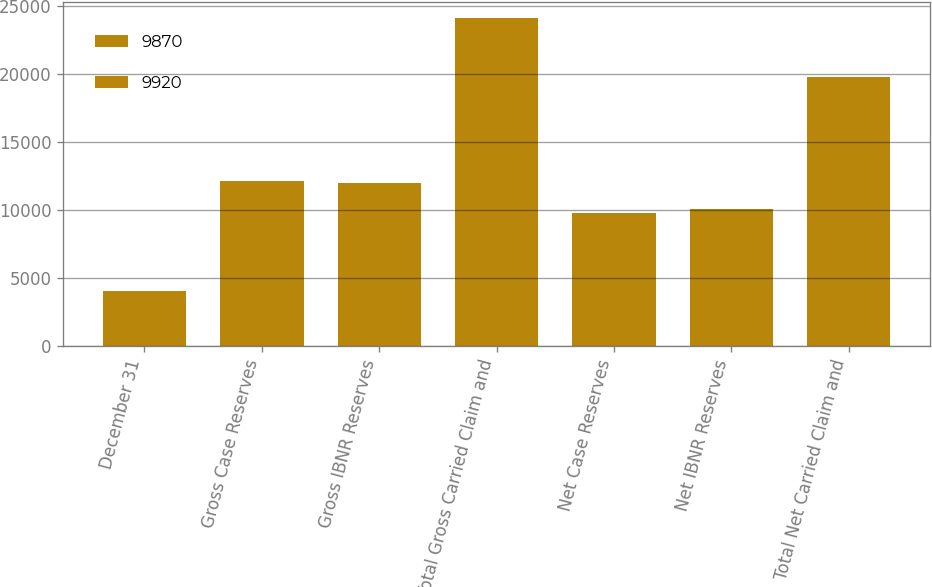Convert chart. <chart><loc_0><loc_0><loc_500><loc_500><stacked_bar_chart><ecel><fcel>December 31<fcel>Gross Case Reserves<fcel>Gross IBNR Reserves<fcel>Total Gross Carried Claim and<fcel>Net Case Reserves<fcel>Net IBNR Reserves<fcel>Total Net Carried Claim and<nl><fcel>9870<fcel>2008<fcel>6158<fcel>5890<fcel>12048<fcel>4995<fcel>4875<fcel>9870<nl><fcel>9920<fcel>2007<fcel>5988<fcel>6060<fcel>12048<fcel>4750<fcel>5170<fcel>9920<nl></chart> 